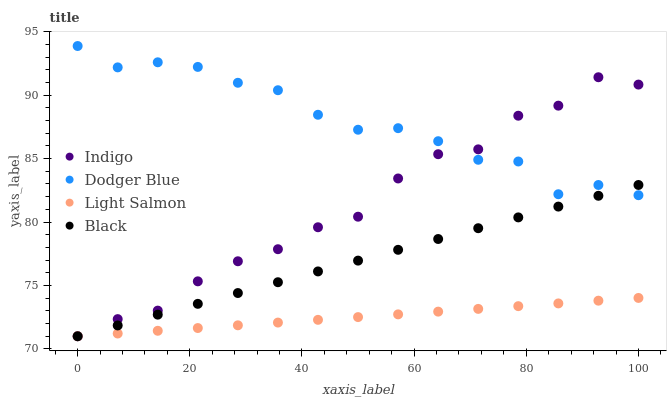Does Light Salmon have the minimum area under the curve?
Answer yes or no. Yes. Does Dodger Blue have the maximum area under the curve?
Answer yes or no. Yes. Does Indigo have the minimum area under the curve?
Answer yes or no. No. Does Indigo have the maximum area under the curve?
Answer yes or no. No. Is Black the smoothest?
Answer yes or no. Yes. Is Indigo the roughest?
Answer yes or no. Yes. Is Light Salmon the smoothest?
Answer yes or no. No. Is Light Salmon the roughest?
Answer yes or no. No. Does Light Salmon have the lowest value?
Answer yes or no. Yes. Does Dodger Blue have the highest value?
Answer yes or no. Yes. Does Indigo have the highest value?
Answer yes or no. No. Is Light Salmon less than Dodger Blue?
Answer yes or no. Yes. Is Dodger Blue greater than Light Salmon?
Answer yes or no. Yes. Does Indigo intersect Dodger Blue?
Answer yes or no. Yes. Is Indigo less than Dodger Blue?
Answer yes or no. No. Is Indigo greater than Dodger Blue?
Answer yes or no. No. Does Light Salmon intersect Dodger Blue?
Answer yes or no. No. 